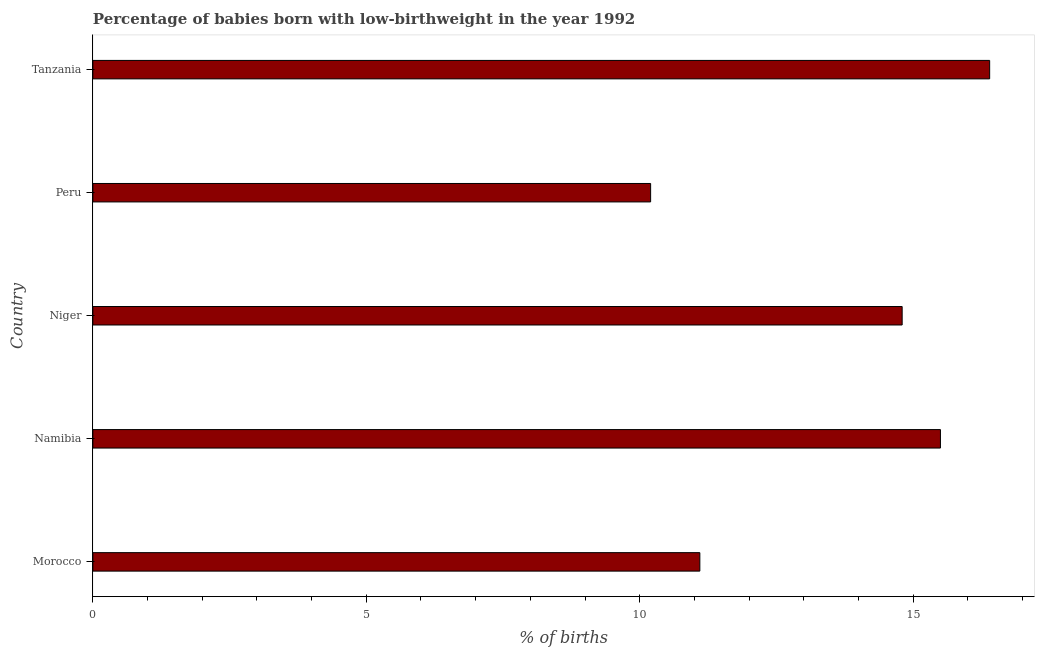Does the graph contain grids?
Make the answer very short. No. What is the title of the graph?
Provide a short and direct response. Percentage of babies born with low-birthweight in the year 1992. What is the label or title of the X-axis?
Your response must be concise. % of births. What is the label or title of the Y-axis?
Make the answer very short. Country. What is the percentage of babies who were born with low-birthweight in Peru?
Ensure brevity in your answer.  10.2. Across all countries, what is the maximum percentage of babies who were born with low-birthweight?
Provide a succinct answer. 16.4. Across all countries, what is the minimum percentage of babies who were born with low-birthweight?
Make the answer very short. 10.2. In which country was the percentage of babies who were born with low-birthweight maximum?
Provide a succinct answer. Tanzania. What is the median percentage of babies who were born with low-birthweight?
Make the answer very short. 14.8. In how many countries, is the percentage of babies who were born with low-birthweight greater than 16 %?
Provide a short and direct response. 1. What is the ratio of the percentage of babies who were born with low-birthweight in Namibia to that in Tanzania?
Keep it short and to the point. 0.94. What is the difference between the highest and the second highest percentage of babies who were born with low-birthweight?
Provide a succinct answer. 0.9. Is the sum of the percentage of babies who were born with low-birthweight in Morocco and Tanzania greater than the maximum percentage of babies who were born with low-birthweight across all countries?
Your answer should be compact. Yes. What is the difference between the highest and the lowest percentage of babies who were born with low-birthweight?
Provide a succinct answer. 6.2. In how many countries, is the percentage of babies who were born with low-birthweight greater than the average percentage of babies who were born with low-birthweight taken over all countries?
Provide a short and direct response. 3. How many bars are there?
Provide a succinct answer. 5. Are all the bars in the graph horizontal?
Your answer should be compact. Yes. How many countries are there in the graph?
Provide a succinct answer. 5. What is the difference between two consecutive major ticks on the X-axis?
Your response must be concise. 5. Are the values on the major ticks of X-axis written in scientific E-notation?
Provide a short and direct response. No. What is the % of births in Morocco?
Offer a very short reply. 11.1. What is the % of births in Namibia?
Ensure brevity in your answer.  15.5. What is the difference between the % of births in Morocco and Namibia?
Offer a very short reply. -4.4. What is the difference between the % of births in Morocco and Peru?
Keep it short and to the point. 0.9. What is the difference between the % of births in Morocco and Tanzania?
Offer a very short reply. -5.3. What is the difference between the % of births in Namibia and Tanzania?
Your answer should be very brief. -0.9. What is the ratio of the % of births in Morocco to that in Namibia?
Keep it short and to the point. 0.72. What is the ratio of the % of births in Morocco to that in Niger?
Offer a terse response. 0.75. What is the ratio of the % of births in Morocco to that in Peru?
Provide a succinct answer. 1.09. What is the ratio of the % of births in Morocco to that in Tanzania?
Your answer should be compact. 0.68. What is the ratio of the % of births in Namibia to that in Niger?
Your answer should be very brief. 1.05. What is the ratio of the % of births in Namibia to that in Peru?
Ensure brevity in your answer.  1.52. What is the ratio of the % of births in Namibia to that in Tanzania?
Provide a short and direct response. 0.94. What is the ratio of the % of births in Niger to that in Peru?
Offer a very short reply. 1.45. What is the ratio of the % of births in Niger to that in Tanzania?
Give a very brief answer. 0.9. What is the ratio of the % of births in Peru to that in Tanzania?
Offer a very short reply. 0.62. 